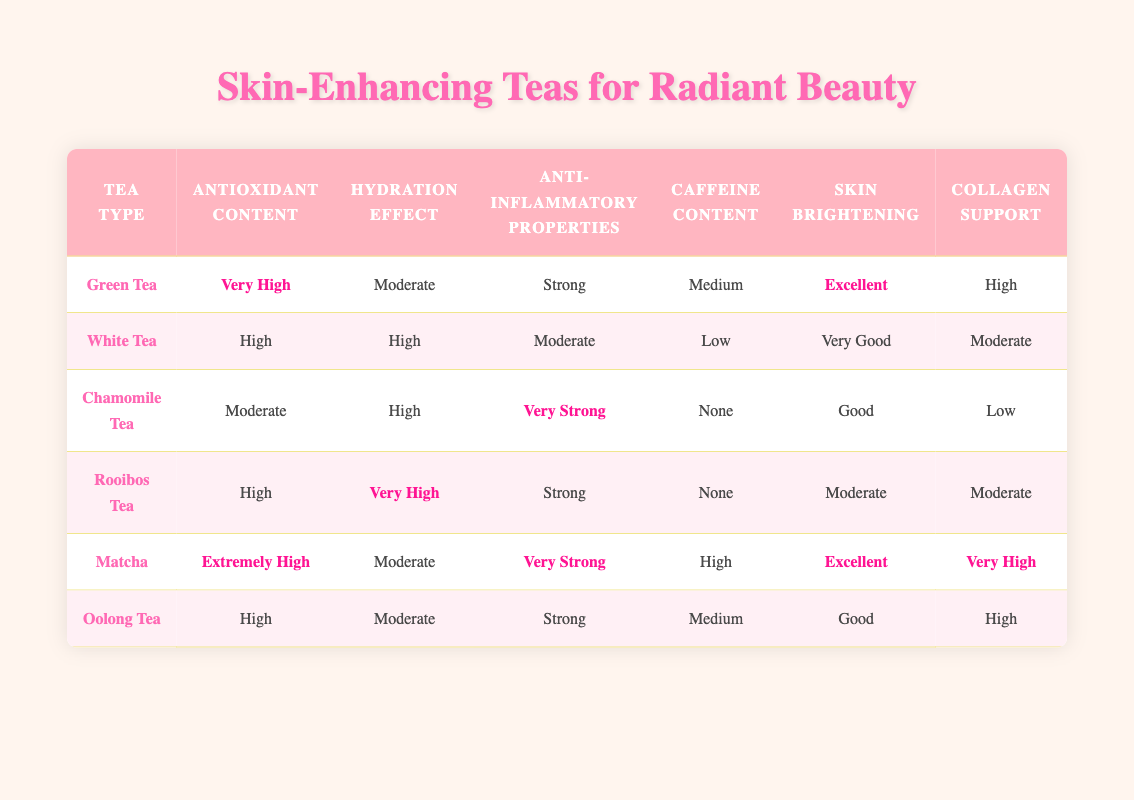What tea type has the highest antioxidant content? By scanning the "Antioxidant Content" column, "Matcha" is listed as having "Extremely High," which is higher than any other tea type.
Answer: Matcha Which tea type has no caffeine? Looking at the "Caffeine Content" column, both "Chamomile Tea" and "Rooibos Tea" have "None" listed under this category.
Answer: Chamomile Tea and Rooibos Tea What is the skin brightening rating for Green Tea? The "Skin Brightening" column indicates that "Green Tea" has an "Excellent" rating, which directly answers the question.
Answer: Excellent How many tea types have "High" collagen support? By checking the "Collagen Support" column, "Green Tea," "Oolong Tea," and "Rooibos Tea" are the three types noted with "High" or better support. This gives a total of 3 tea types.
Answer: 3 Is Chamomile Tea stronger in anti-inflammatory properties than Rooibos Tea? In the "Anti-Inflammatory Properties" column, Chamomile Tea is noted for having "Very Strong," while Rooibos Tea is noted as "Strong." Since "Very Strong" is a higher rating, the answer is yes.
Answer: Yes What is the average antioxidant content of Oolong and White Teas? Oolong Tea is rated "High" and White Tea is rated "High." Since they are both rated the same, their average is also "High." Therefore, adding and dividing by 2 confirms this.
Answer: High Which tea has both excellent skin brightening and very high collagen support? By examining the "Skin Brightening" and "Collagen Support" columns, only "Matcha" has "Excellent" for skin brightening and "Very High" for collagen support.
Answer: Matcha Does White Tea provide more hydration than Green Tea? The "Hydration Effect" of White Tea is categorized as "High," while Green Tea is rated "Moderate." Since high is greater than moderate, White Tea provides more hydration.
Answer: Yes Which tea has the lowest anti-inflammatory properties? Comparing the "Anti-Inflammatory Properties" column, Chamomile Tea has an entry of "Very Strong," Rooibos and others at "Strong" or "Moderate," which means "Chamomile Tea" is not the lowest. The answer is Rooibos and Chamomile Tea has the lowest anti-inflammatory rating.
Answer: Chamomile Tea 